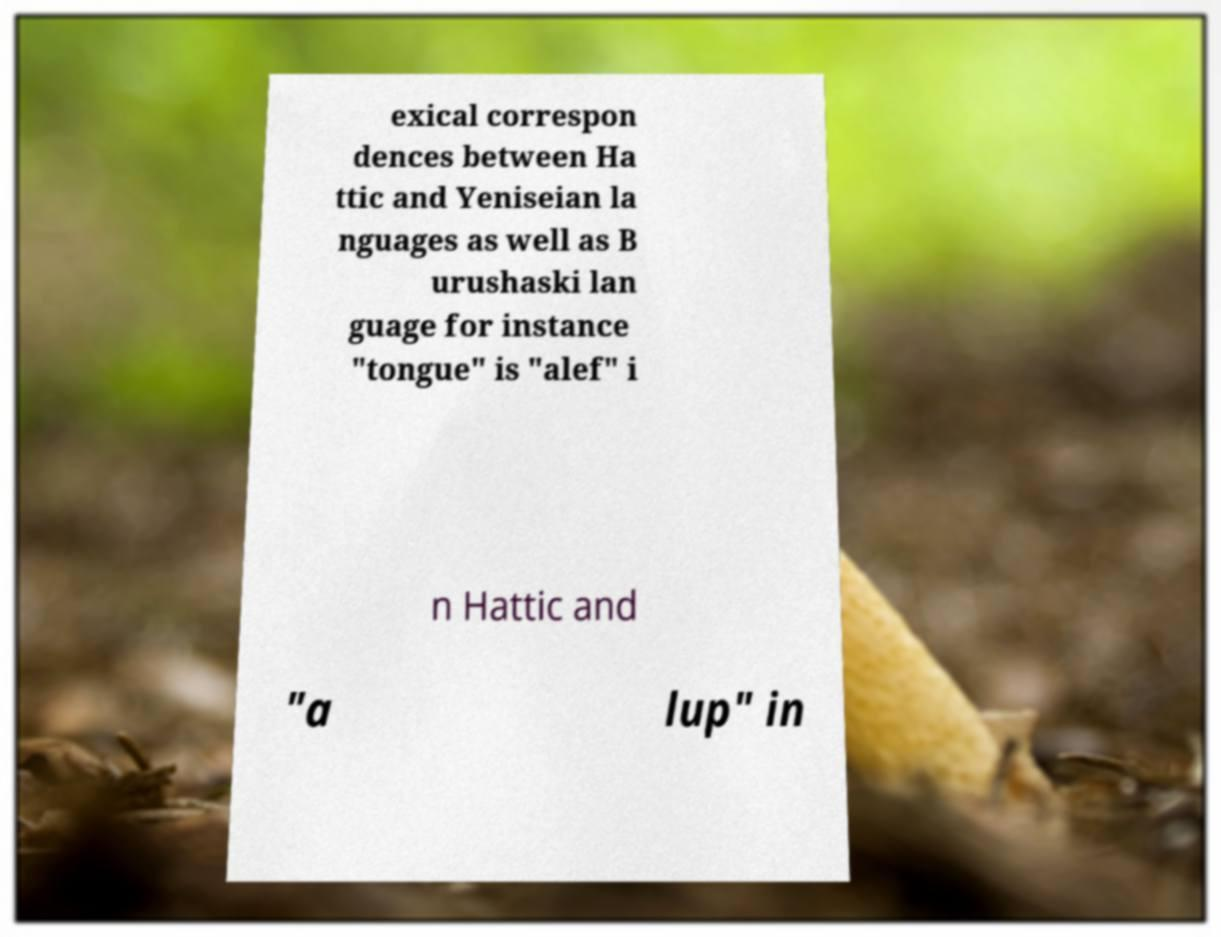There's text embedded in this image that I need extracted. Can you transcribe it verbatim? exical correspon dences between Ha ttic and Yeniseian la nguages as well as B urushaski lan guage for instance "tongue" is "alef" i n Hattic and "a lup" in 